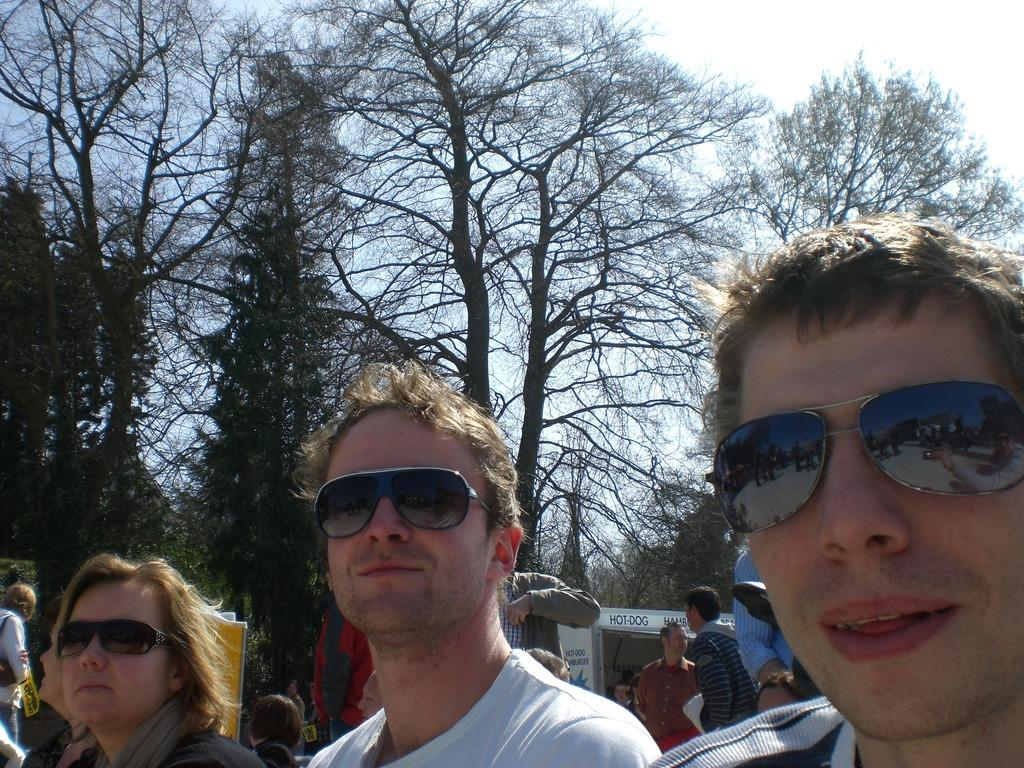<image>
Summarize the visual content of the image. A group of people wearing sunglasses are standing in front of a stand that says Hot Dog. 